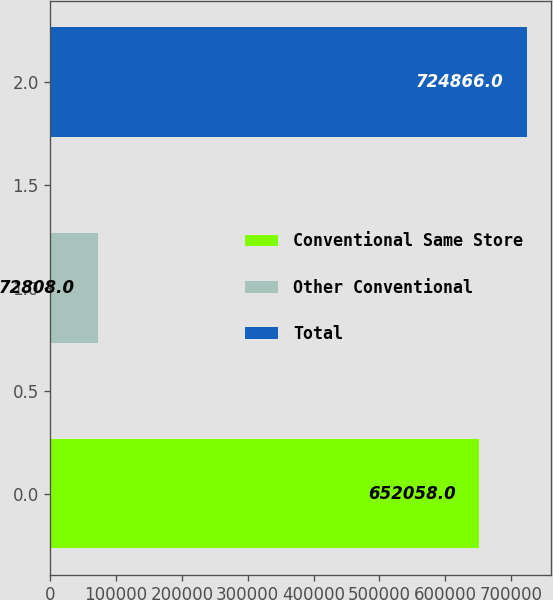Convert chart. <chart><loc_0><loc_0><loc_500><loc_500><bar_chart><fcel>Conventional Same Store<fcel>Other Conventional<fcel>Total<nl><fcel>652058<fcel>72808<fcel>724866<nl></chart> 